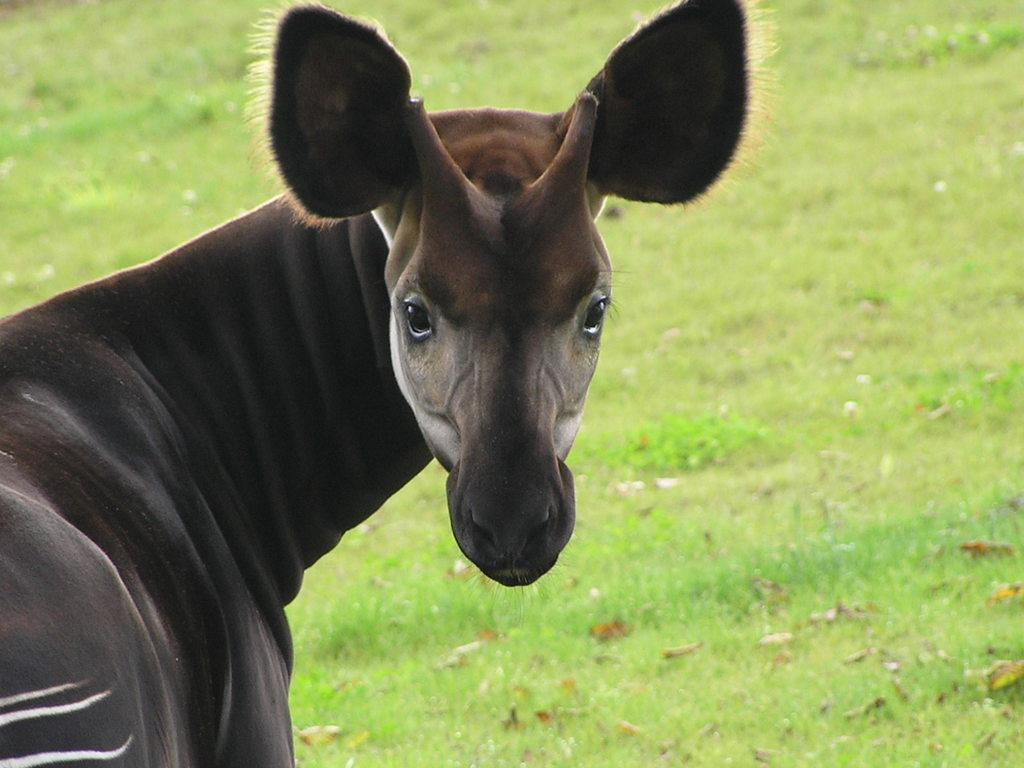What type of animal is present in the image? There is an animal in the image, but the specific type cannot be determined from the provided facts. What is the ground covered with in the image? The ground is covered with grass and leaves in the image. What type of humor can be seen in the animal's expression in the image? There is no indication of the animal's expression or any humor in the image, as the specific type of animal cannot be determined. 